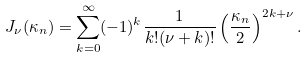Convert formula to latex. <formula><loc_0><loc_0><loc_500><loc_500>J _ { \nu } ( \kappa _ { n } ) = \sum _ { k = 0 } ^ { \infty } ( - 1 ) ^ { k } \frac { 1 } { k ! ( \nu + k ) ! } \left ( \frac { \kappa _ { n } } { 2 } \right ) ^ { 2 k + \nu } .</formula> 